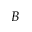Convert formula to latex. <formula><loc_0><loc_0><loc_500><loc_500>B</formula> 